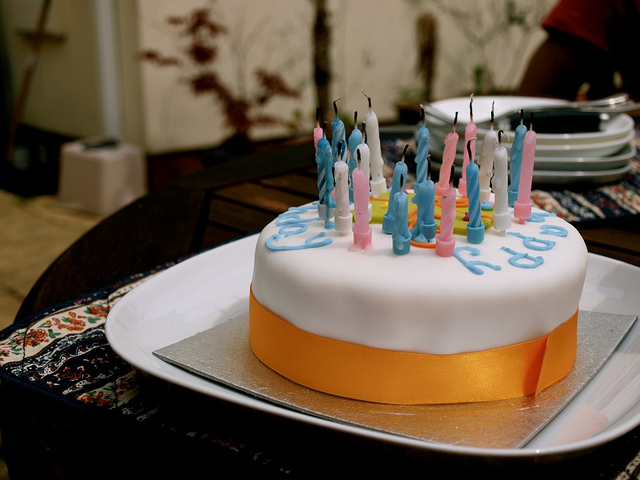Please extract the text content from this image. happy 